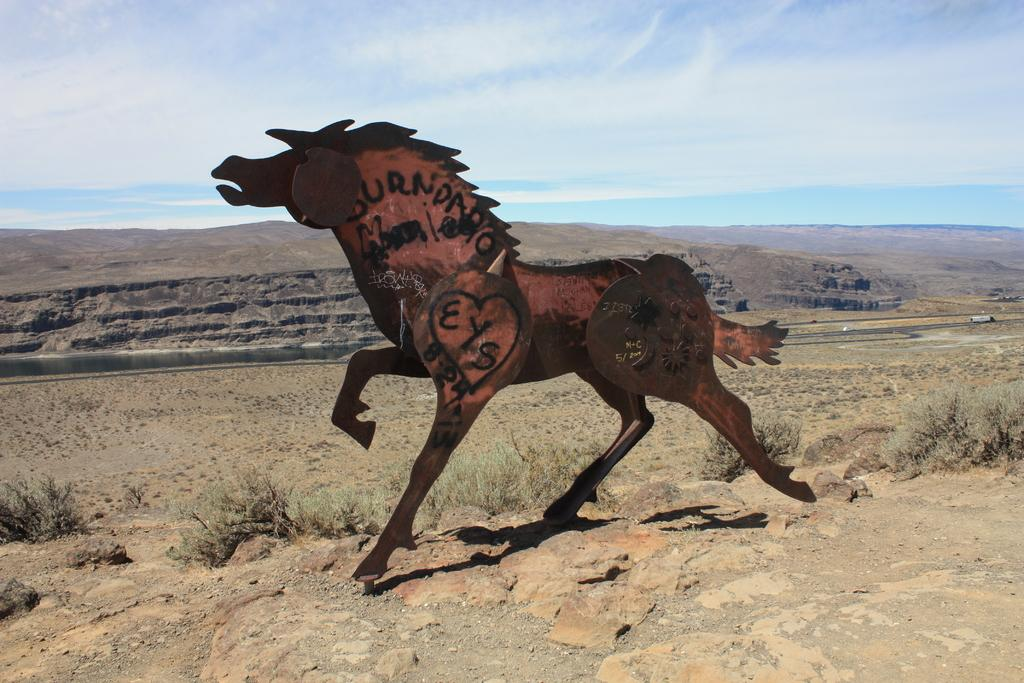What is the main subject on the ground in the image? There is a statue of a horse on the ground. What type of vegetation is present in the image? There are plants in the image. What can be seen in the background of the image? The sky is visible in the background of the image. What type of debt is the horse statue trying to pay off in the image? There is no indication of debt or any financial context in the image; it features a statue of a horse on the ground. What type of reward is the horse statue holding in the image? There is no reward or any prize-related context in the image; it features a statue of a horse on the ground. 